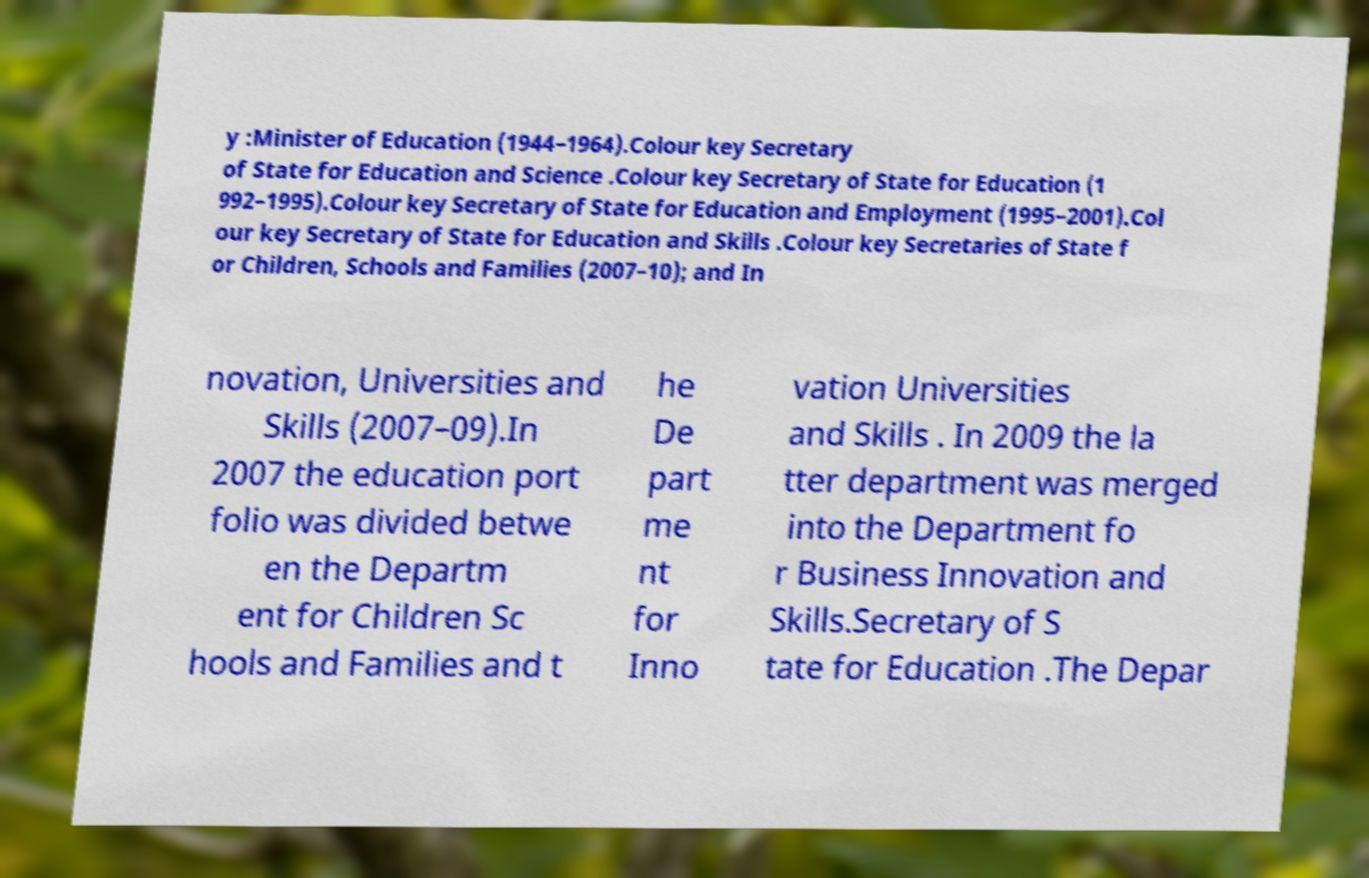Please identify and transcribe the text found in this image. y :Minister of Education (1944–1964).Colour key Secretary of State for Education and Science .Colour key Secretary of State for Education (1 992–1995).Colour key Secretary of State for Education and Employment (1995–2001).Col our key Secretary of State for Education and Skills .Colour key Secretaries of State f or Children, Schools and Families (2007–10); and In novation, Universities and Skills (2007–09).In 2007 the education port folio was divided betwe en the Departm ent for Children Sc hools and Families and t he De part me nt for Inno vation Universities and Skills . In 2009 the la tter department was merged into the Department fo r Business Innovation and Skills.Secretary of S tate for Education .The Depar 